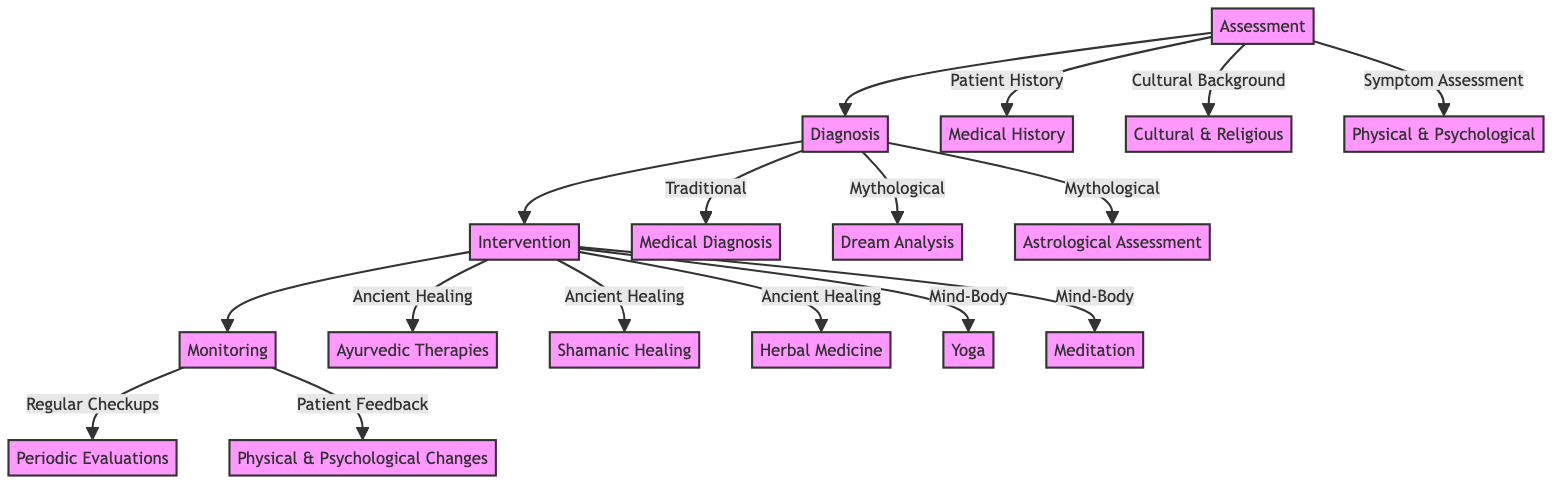What are the components involved in the Assessment phase? The Assessment phase includes three components: Patient History, Cultural Background, and Symptom Assessment, as indicated by the arrows leading to the A node.
Answer: Patient History, Cultural Background, Symptom Assessment How many types of Mythological Diagnostic Techniques are there? In the Diagnosis phase, there are two types of Mythological Diagnostic Techniques identified: Dream Analysis and Astrological Assessment. Thus, the count is two.
Answer: 2 Which intervention focuses on Mind-Body techniques? The Mind-Body Interventions section lists Yoga and Meditation as the relevant techniques that fall under this category as indicated in the C node's branching.
Answer: Yoga, Meditation What type of checkups are scheduled in the Monitoring phase? The Monitoring phase indicates that Regular Checkups are scheduled, as illustrated by the arrow from C to D1.
Answer: Regular Checkups What are the two types of interventions mentioned in the diagram? The diagram specifies two primary categories of interventions: Ancient Healing Rituals and Mind-Body Interventions, evident from the branching under C.
Answer: Ancient Healing Rituals, Mind-Body Interventions How is patient feedback utilized in the Monitoring process? Patient feedback is collected to assess changes in physical and psychological conditions, which is shown by the arrow leading to D2 in the Monitoring phase.
Answer: Patient Feedback What are the specific techniques included in Ancient Healing Rituals? The Ancient Healing Rituals section outlines three distinct techniques: Ayurvedic Therapies, Shamanic Healing, and Herbal Medicine, as shown by their respective nodes under C.
Answer: Ayurvedic Therapies, Shamanic Healing, Herbal Medicine What is the main purpose of the Assessment phase? The Assessment phase serves to evaluate a patient's history, cultural background, and current symptoms to inform subsequent steps in the pathway, which can be inferred from the connections to the B node.
Answer: Evaluate patient's background and symptoms 